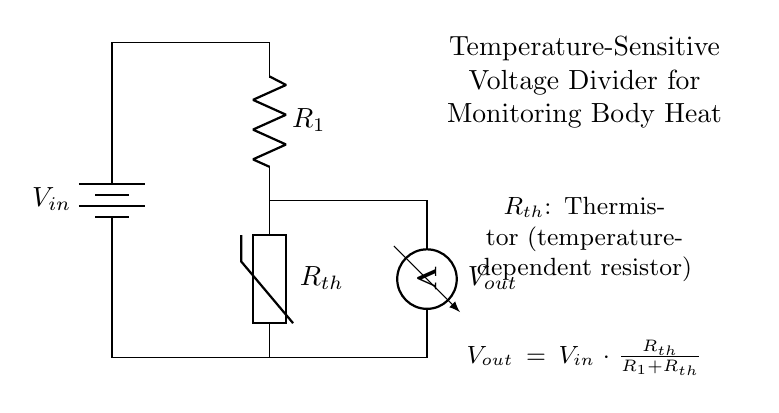What is the role of the thermistor in this circuit? The thermistor is a temperature-sensitive resistor which changes resistance based on temperature variations. Its role is to create a variable resistance in the voltage divider, allowing for a measurable output voltage that corresponds to body heat.
Answer: Thermistor What is the formula for the output voltage? The output voltage \( V_{out} \) is calculated using the formula \( V_{out} = V_{in} \cdot \frac{R_{th}}{R_1 + R_{th}} \). This formula represents the division of the input voltage across the resistors in the circuit, considering the thermistor's resistance.
Answer: Vout = Vin * (Rth / (R1 + Rth)) Which component determines the change in resistance with temperature? The component that changes resistance with temperature is the thermistor. This property allows the voltage divider to produce varying output voltage based on the temperature it senses.
Answer: Thermistor What type of circuit is depicted in the diagram? The circuit depicted is a voltage divider circuit. It uses two resistors, where one is a thermistor, to divide the input voltage into a variable output voltage based on the temperature changes.
Answer: Voltage divider What happens to Vout as temperature increases? As temperature increases, the resistance of the thermistor generally decreases, leading to a higher output voltage \( V_{out} \) according to the voltage divider formula.
Answer: Vout increases What does R1 represent in this circuit? In this circuit, \( R_1 \) is a fixed resistor that works in conjunction with the thermistor to establish a baseline voltage level and help define the output voltage behavior with temperature changes.
Answer: Fixed resistor 